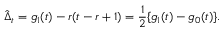Convert formula to latex. <formula><loc_0><loc_0><loc_500><loc_500>\hat { \Delta } _ { t } = g _ { 1 } ( t ) - r ( t - r + 1 ) = \frac { 1 } { 2 } \{ g _ { 1 } ( t ) - g _ { 0 } ( t ) \} .</formula> 